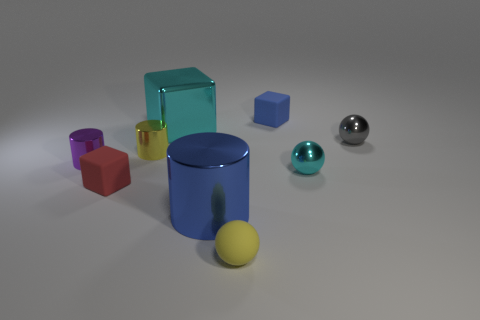How many small metal objects have the same color as the metal cube?
Give a very brief answer. 1. What number of things are either purple metallic cubes or small purple cylinders?
Your response must be concise. 1. The large object in front of the cube that is in front of the yellow metallic thing is made of what material?
Make the answer very short. Metal. Are there any big red balls made of the same material as the small blue object?
Offer a very short reply. No. The thing behind the big metallic object behind the cyan metal thing that is to the right of the tiny blue rubber object is what shape?
Provide a succinct answer. Cube. What is the material of the tiny gray object?
Give a very brief answer. Metal. The block that is made of the same material as the yellow cylinder is what color?
Offer a very short reply. Cyan. Are there any small blue matte things in front of the small sphere in front of the red matte thing?
Provide a succinct answer. No. How many other things are there of the same shape as the tiny yellow matte object?
Your response must be concise. 2. There is a big object behind the red object; does it have the same shape as the rubber thing behind the small purple metal cylinder?
Give a very brief answer. Yes. 